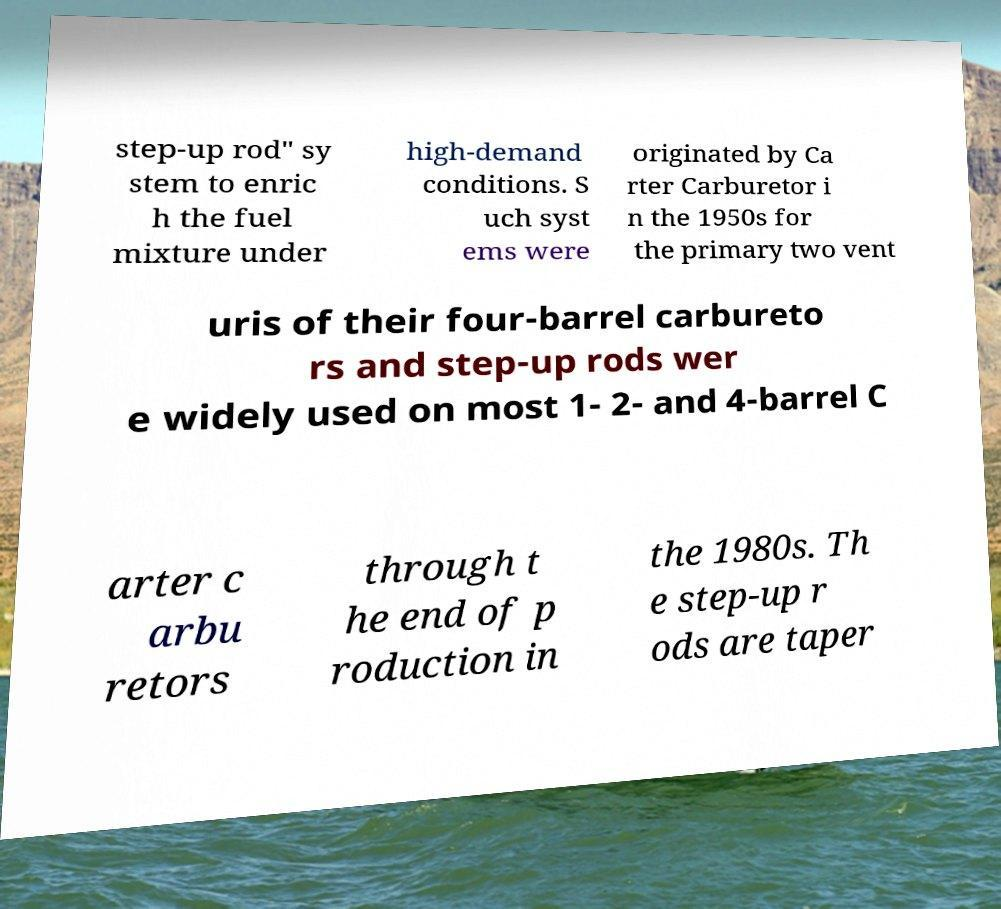What messages or text are displayed in this image? I need them in a readable, typed format. step-up rod" sy stem to enric h the fuel mixture under high-demand conditions. S uch syst ems were originated by Ca rter Carburetor i n the 1950s for the primary two vent uris of their four-barrel carbureto rs and step-up rods wer e widely used on most 1- 2- and 4-barrel C arter c arbu retors through t he end of p roduction in the 1980s. Th e step-up r ods are taper 